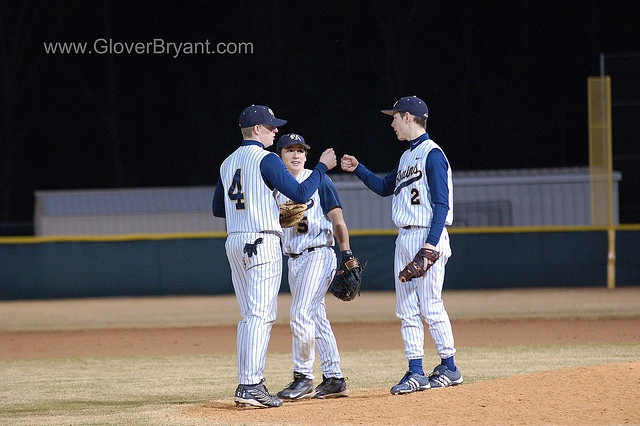Describe the objects in this image and their specific colors. I can see people in black, lavender, darkgray, and navy tones, people in black, lavender, darkgray, and navy tones, people in black, lavender, and darkgray tones, baseball glove in black, gray, and maroon tones, and baseball glove in black, gray, purple, and maroon tones in this image. 